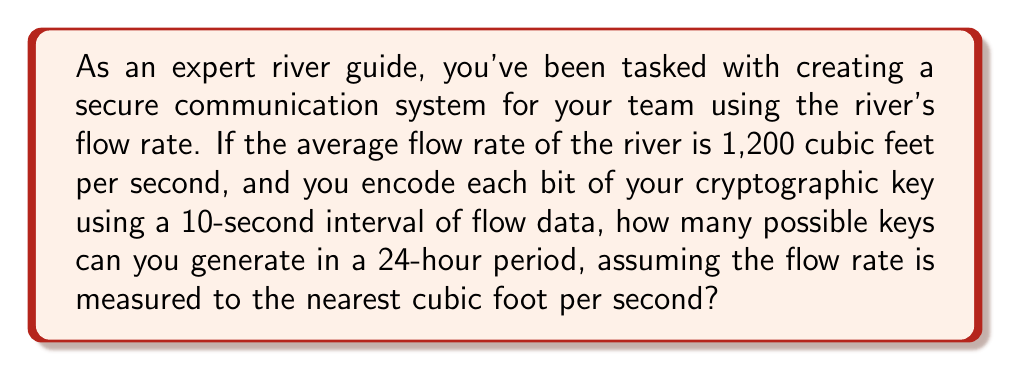Give your solution to this math problem. Let's break this down step-by-step:

1) First, we need to calculate how many 10-second intervals are in a 24-hour period:
   $$24 \text{ hours} \times 60 \text{ minutes/hour} \times 60 \text{ seconds/minute} = 86,400 \text{ seconds}$$
   $$\text{Number of intervals} = \frac{86,400 \text{ seconds}}{10 \text{ seconds/interval}} = 8,640 \text{ intervals}$$

2) Each interval represents one bit in our key. The number of possible values for each bit depends on the range of possible flow rates.

3) Given that the flow rate is measured to the nearest cubic foot per second, and the average is 1,200 cubic feet per second, let's assume a reasonable range of ±20% around this average:
   $$\text{Range} = 1,200 \pm 20\% = 960 \text{ to } 1,440 \text{ cubic feet per second}$$

4) This gives us 481 possible values for each 10-second interval (1,440 - 960 + 1 = 481).

5) With 8,640 intervals, each having 481 possible values, the total number of possible keys is:
   $$481^{8,640}$$

6) This is an enormously large number. To express it more concisely, we can use the properties of exponents:
   $$481^{8,640} = 2^{\log_2(481^{8,640})} = 2^{8,640 \log_2(481)} \approx 2^{75,727}$$

Therefore, the number of possible keys that can be generated in a 24-hour period is approximately $2^{75,727}$.
Answer: $2^{75,727}$ 